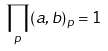<formula> <loc_0><loc_0><loc_500><loc_500>\prod _ { p } ( a , b ) _ { p } = 1</formula> 